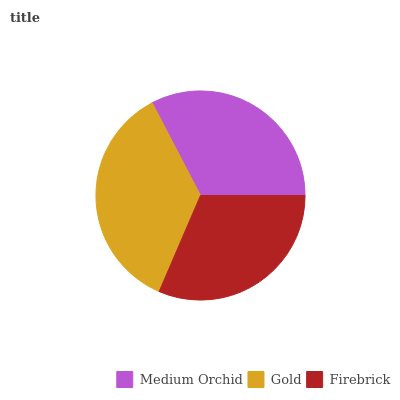Is Firebrick the minimum?
Answer yes or no. Yes. Is Gold the maximum?
Answer yes or no. Yes. Is Gold the minimum?
Answer yes or no. No. Is Firebrick the maximum?
Answer yes or no. No. Is Gold greater than Firebrick?
Answer yes or no. Yes. Is Firebrick less than Gold?
Answer yes or no. Yes. Is Firebrick greater than Gold?
Answer yes or no. No. Is Gold less than Firebrick?
Answer yes or no. No. Is Medium Orchid the high median?
Answer yes or no. Yes. Is Medium Orchid the low median?
Answer yes or no. Yes. Is Gold the high median?
Answer yes or no. No. Is Firebrick the low median?
Answer yes or no. No. 